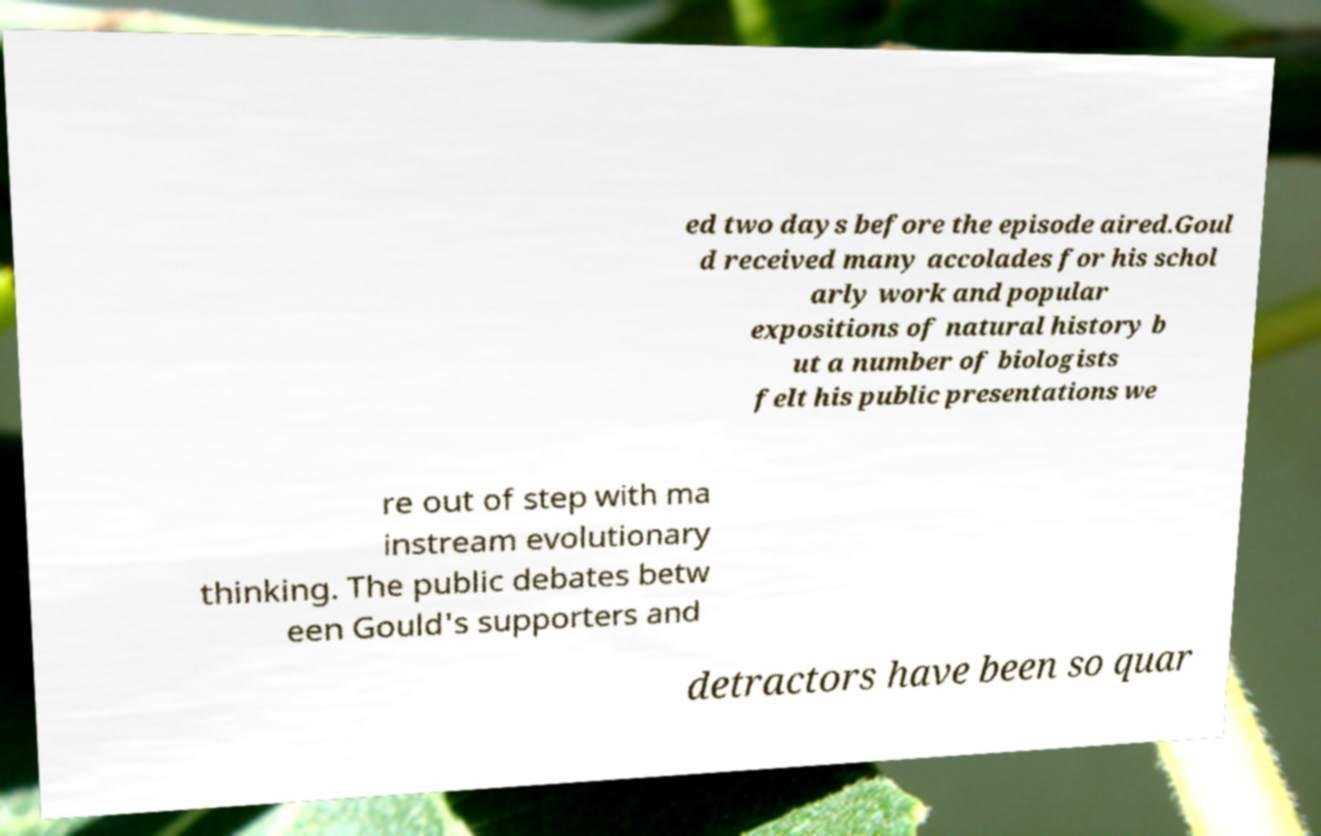I need the written content from this picture converted into text. Can you do that? ed two days before the episode aired.Goul d received many accolades for his schol arly work and popular expositions of natural history b ut a number of biologists felt his public presentations we re out of step with ma instream evolutionary thinking. The public debates betw een Gould's supporters and detractors have been so quar 